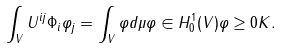<formula> <loc_0><loc_0><loc_500><loc_500>\int _ { V } U ^ { i j } \Phi _ { i } \varphi _ { j } = \int _ { V } \varphi d \mu \varphi \in H ^ { 1 } _ { 0 } ( V ) \varphi \geq 0 K .</formula> 